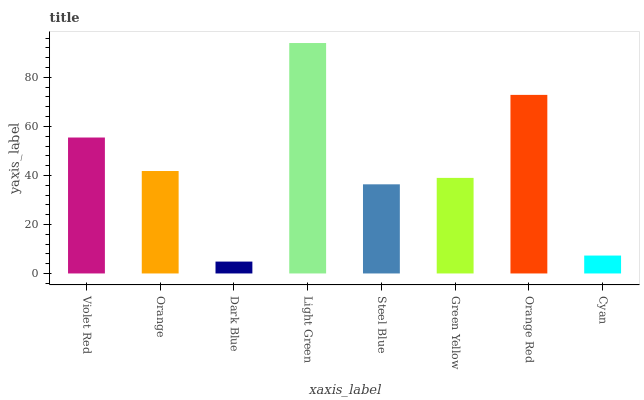Is Dark Blue the minimum?
Answer yes or no. Yes. Is Light Green the maximum?
Answer yes or no. Yes. Is Orange the minimum?
Answer yes or no. No. Is Orange the maximum?
Answer yes or no. No. Is Violet Red greater than Orange?
Answer yes or no. Yes. Is Orange less than Violet Red?
Answer yes or no. Yes. Is Orange greater than Violet Red?
Answer yes or no. No. Is Violet Red less than Orange?
Answer yes or no. No. Is Orange the high median?
Answer yes or no. Yes. Is Green Yellow the low median?
Answer yes or no. Yes. Is Steel Blue the high median?
Answer yes or no. No. Is Light Green the low median?
Answer yes or no. No. 